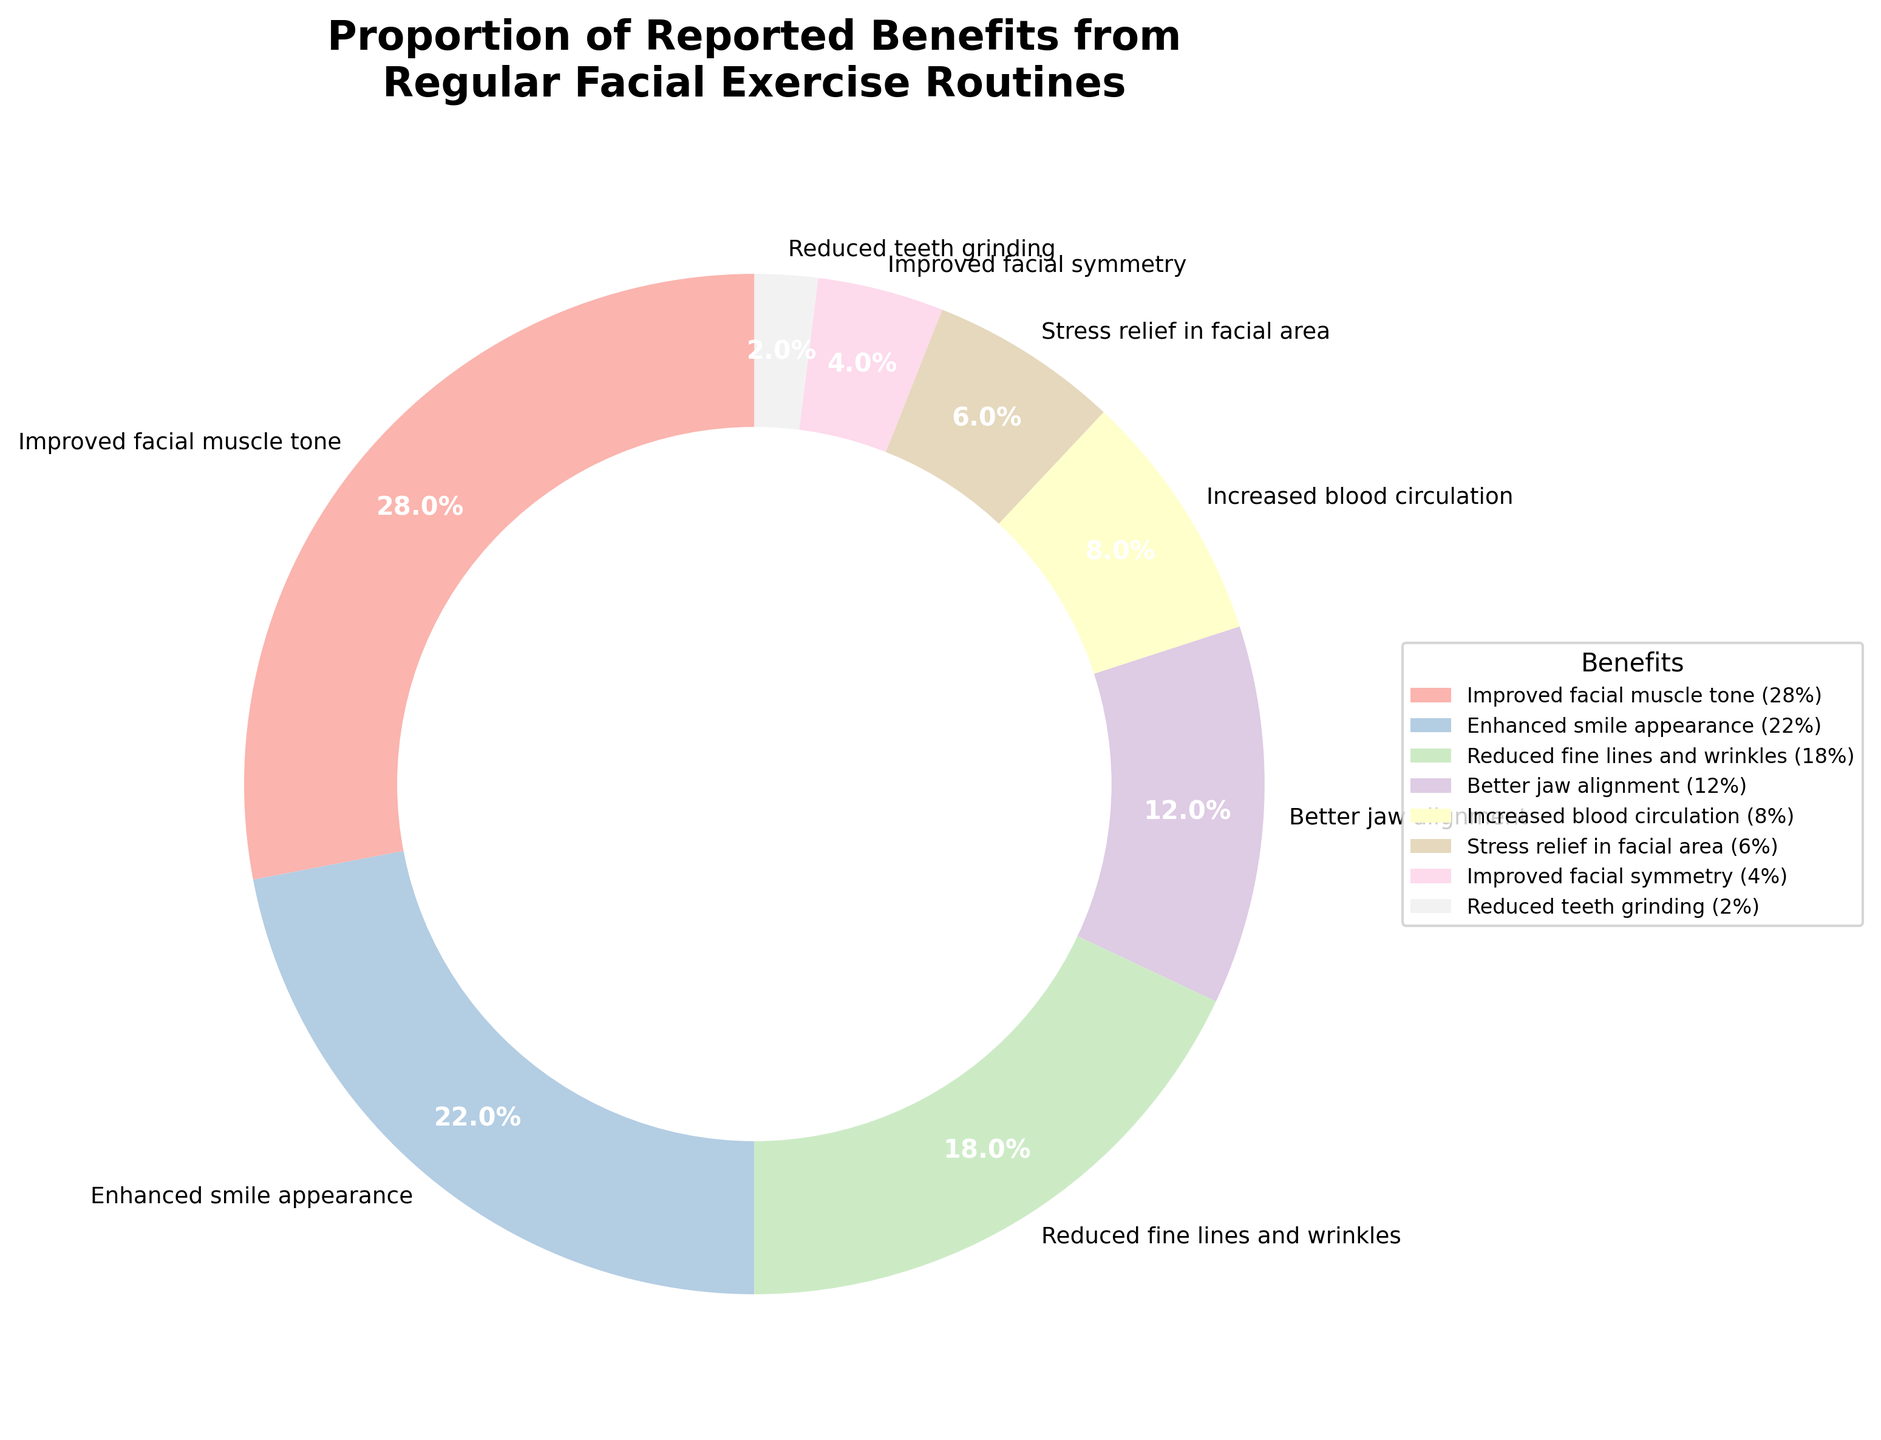Which benefit is reported the most from regular facial exercise routines? The benefit with the highest percentage is 'Improved facial muscle tone', represented by the segment taking up 28% of the pie chart.
Answer: Improved facial muscle tone How much larger is the percentage of 'Enhanced smile appearance' compared to 'Reduced teeth grinding'? The percentage for 'Enhanced smile appearance' is 22%, and for 'Reduced teeth grinding' it is 2%. The difference is 22% - 2% = 20%.
Answer: 20% What is the combined percentage of 'Improved facial muscle tone' and 'Enhanced smile appearance'? 'Improved facial muscle tone' is 28% and 'Enhanced smile appearance' is 22%. Their combined percentage is 28% + 22% = 50%.
Answer: 50% Which benefit has the smallest proportion from regular facial exercise routines? 'Reduced teeth grinding' has the smallest proportion with 2% as represented by the smallest slice of the pie chart.
Answer: Reduced teeth grinding Is the percentage of 'Better jaw alignment' more or less than half of 'Improved facial muscle tone'? 'Better jaw alignment' is 12% and 'Improved facial muscle tone' is 28%. Half of 'Improved facial muscle tone' is 28% / 2 = 14%, and 12% is less than 14%.
Answer: Less How do 'Reduced fine lines and wrinkles' and 'Stress relief in facial area' compare in percentage terms? The percentage for 'Reduced fine lines and wrinkles' is 18%, while 'Stress relief in facial area' is 6%. Comparing these, 18% is greater than 6%.
Answer: Reduced fine lines and wrinkles > Stress relief in facial area What is the sum of the percentages for 'Increased blood circulation' and 'Improved facial symmetry'? 'Increased blood circulation' is 8%, and 'Improved facial symmetry' is 4%. Their sum is 8% + 4% = 12%.
Answer: 12% Which benefit falls in the range of 10-20% in terms of reported benefits? 'Reduced fine lines and wrinkles' at 18% and 'Better jaw alignment' at 12% both fall within the 10-20% range.
Answer: Reduced fine lines and wrinkles, Better jaw alignment If the total percentage must sum to 100%, how would you verify accuracy based on the given data? Add all the individual percentages: 28% + 22% + 18% + 12% + 8% + 6% + 4% + 2% = 100%, thus confirming the accuracy.
Answer: 100% 